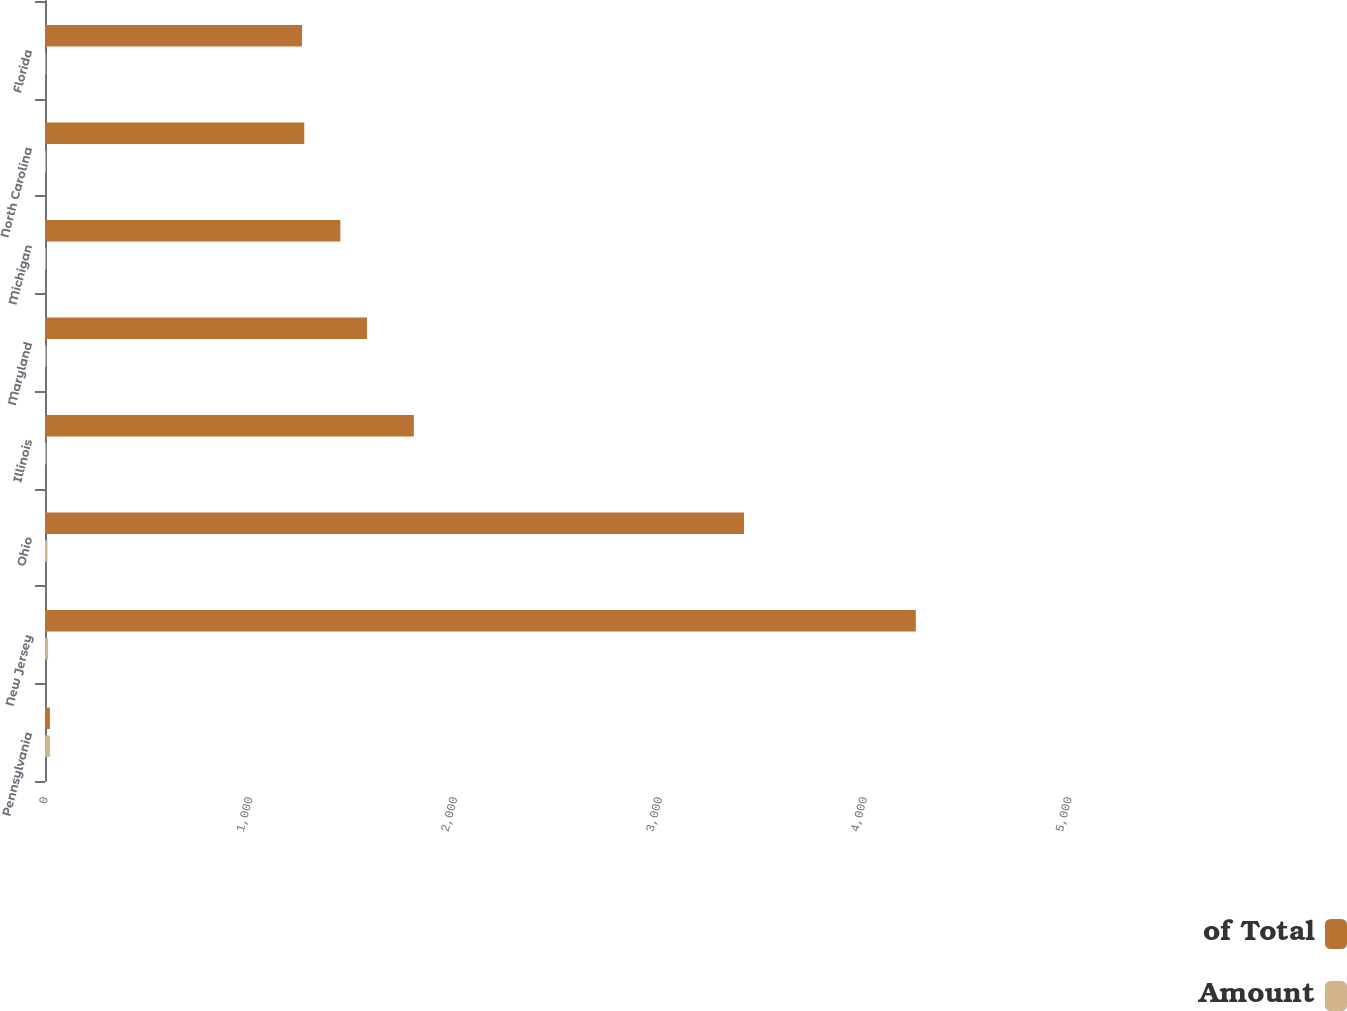Convert chart. <chart><loc_0><loc_0><loc_500><loc_500><stacked_bar_chart><ecel><fcel>Pennsylvania<fcel>New Jersey<fcel>Ohio<fcel>Illinois<fcel>Maryland<fcel>Michigan<fcel>North Carolina<fcel>Florida<nl><fcel>of Total<fcel>24<fcel>4252<fcel>3413<fcel>1801<fcel>1572<fcel>1442<fcel>1266<fcel>1255<nl><fcel>Amount<fcel>24<fcel>15<fcel>12<fcel>6<fcel>6<fcel>5<fcel>5<fcel>4<nl></chart> 